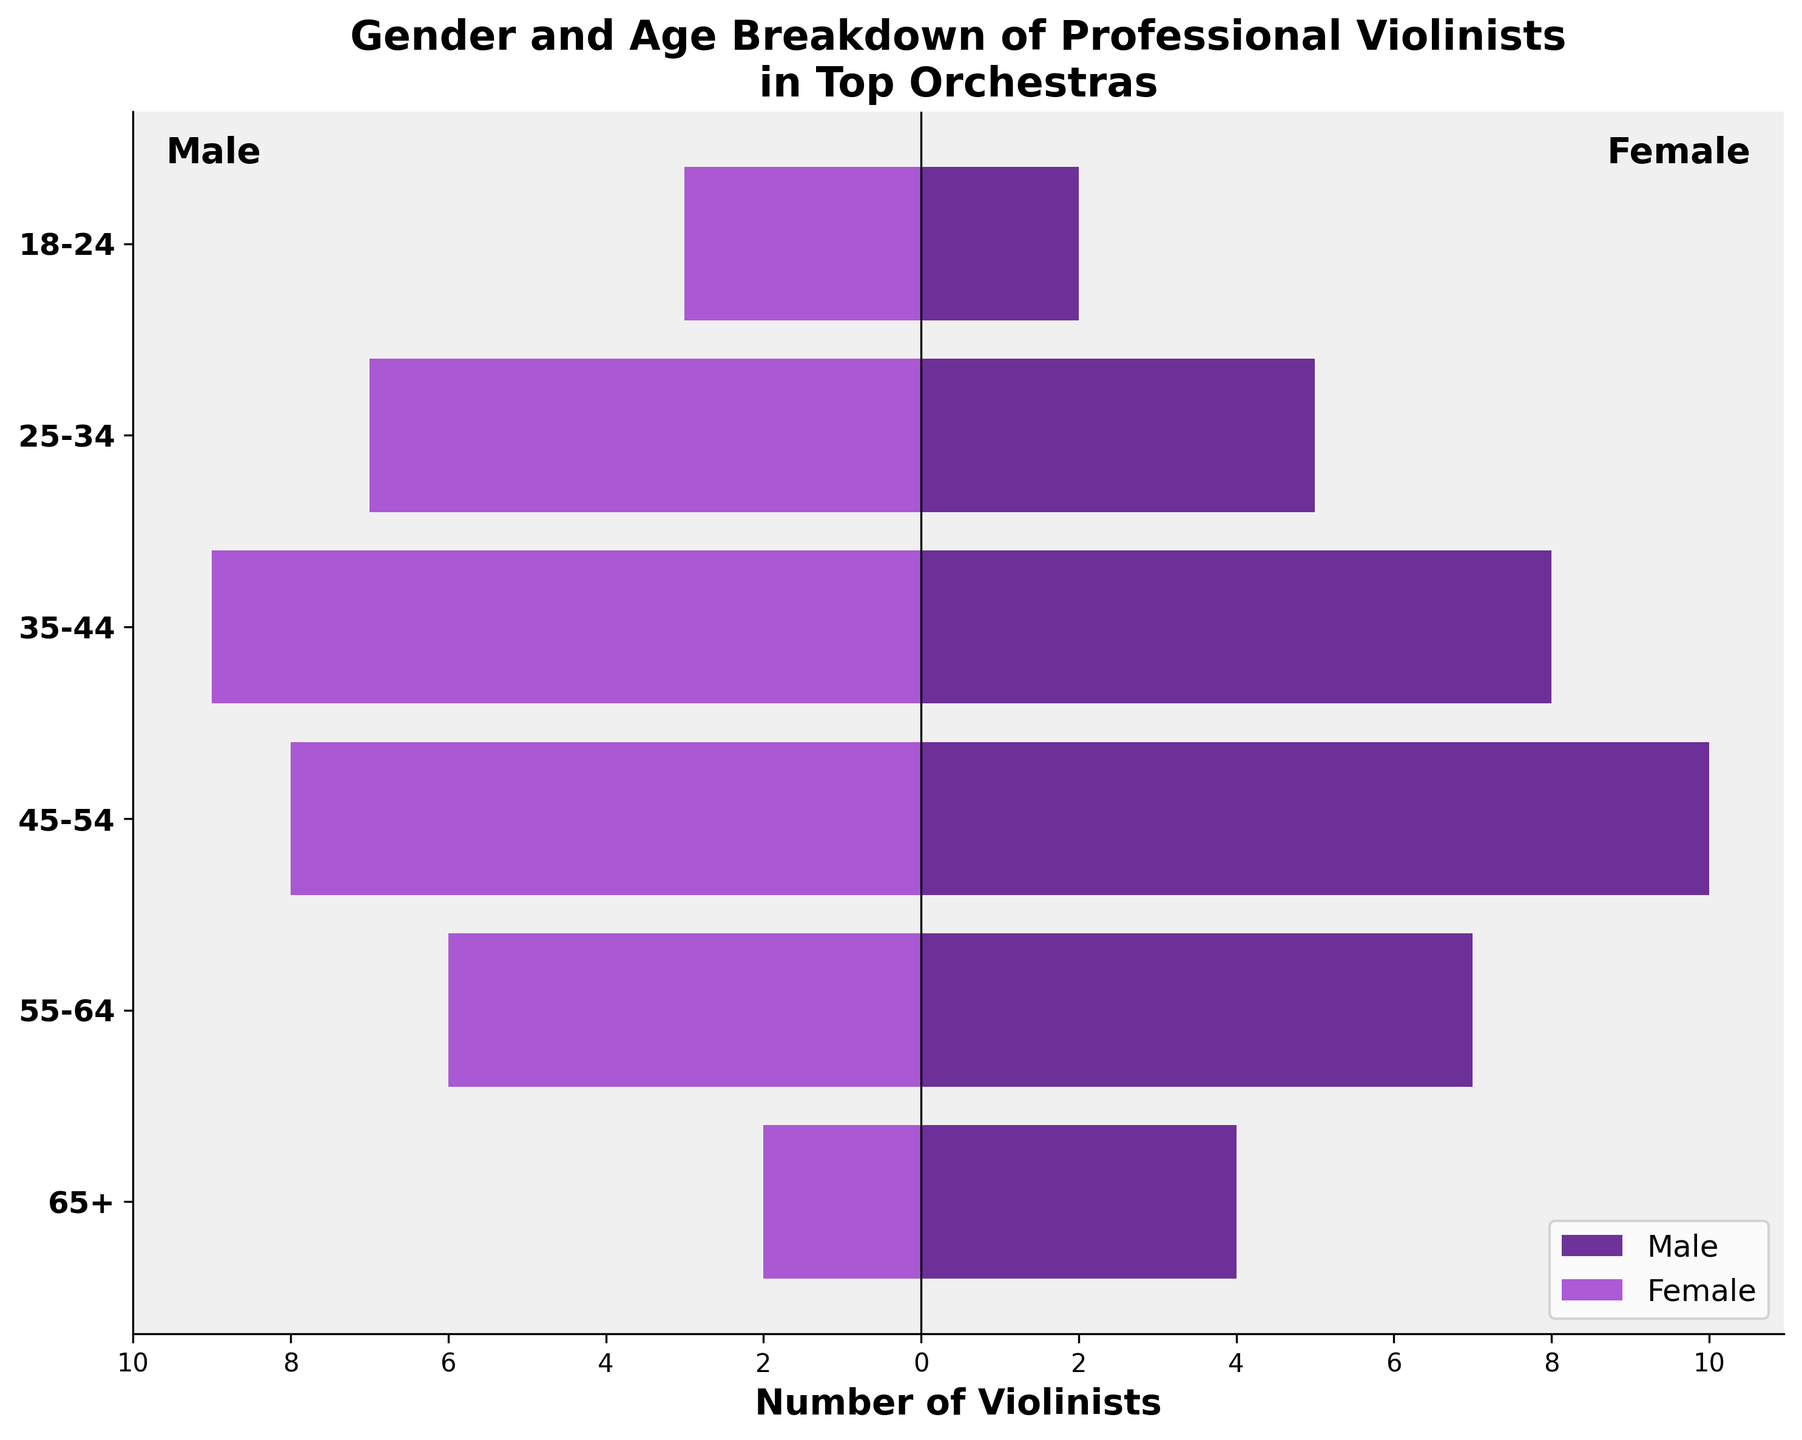What's the title of the figure? The title can be found at the top of the figure. It serves to provide viewers with a concise description of what the figure represents.
Answer: Gender and Age Breakdown of Professional Violinists in Top Orchestras What is the color used for representing male violinists in the chart? The color used for each gender can be identified by looking at the legend at the bottom right of the figure.
Answer: Purple How many male violinists are aged 45-54? Refer to the horizontal bar on the left side for the 45-54 age group and read the length of the bar.
Answer: 10 Which age group has the highest number of female violinists? Compare the lengths of the bars on the right side for each age group to determine which is the longest.
Answer: 35-44 What is the total number of male violinists in the 35-44 age group and the 55-64 age group? Add the number of male violinists in 35-44 (8) and 55-64 (7) age groups together.
Answer: 15 Which age group has a higher number of violinists, 18-24 or 65+? Compare the total lengths of the bars (both male and female) for the age groups 18-24 and 65+.
Answer: 18-24 Is the number of female violinists in the 25-34 age group greater than the number of male violinists in the same group? Compare the length of the bars on the right for females and on the left for males in the 25-34 age group.
Answer: Yes What is the difference between the number of male and female violinists in the 55-64 age group? Find and subtract the number of female violinists from the number of male violinists in the 55-64 age group.
Answer: 1 